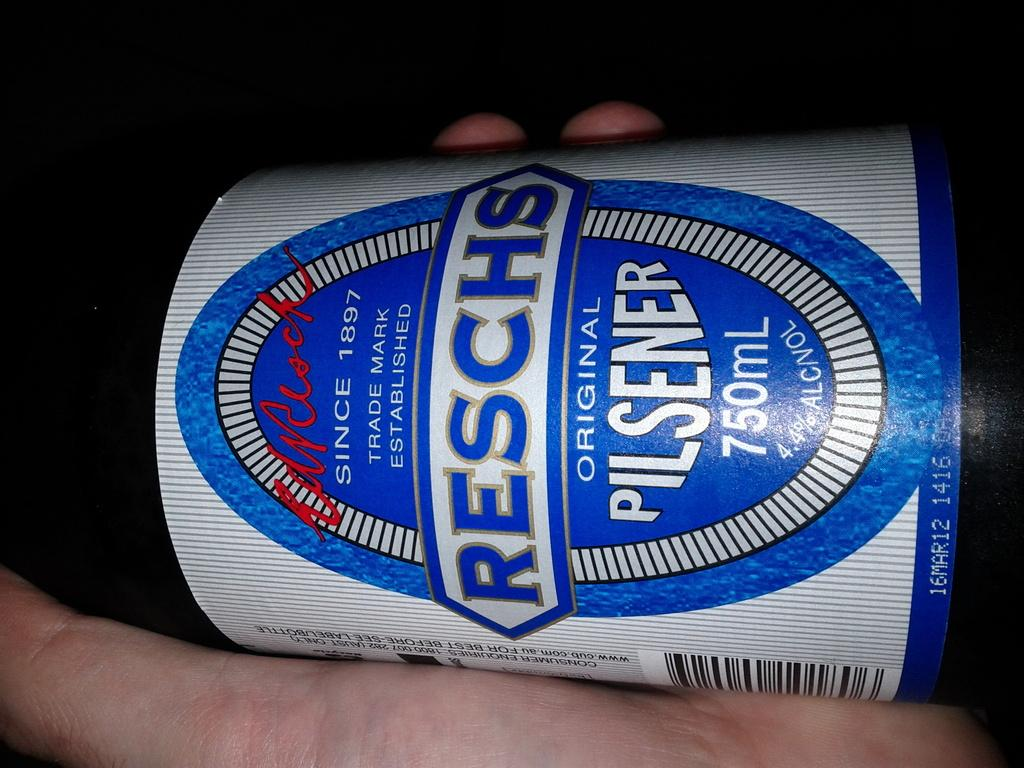Provide a one-sentence caption for the provided image. A hand holds a bottle of Reschs pilsener. 